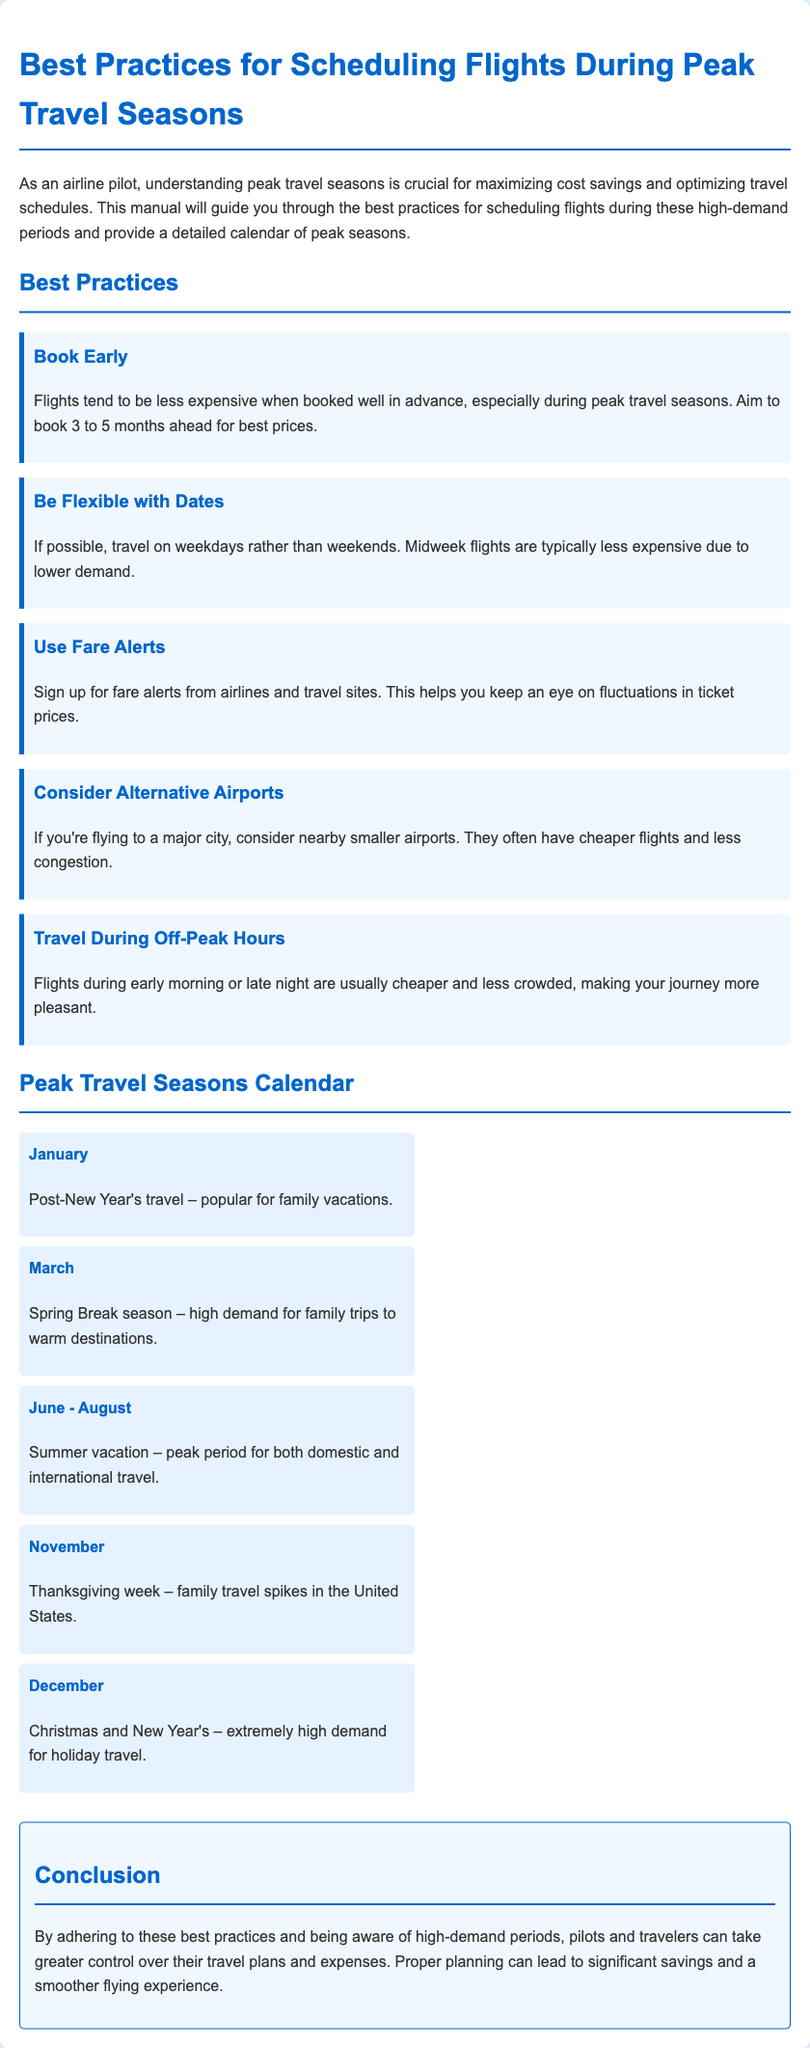what is a best practice for booking flights? The document states that booking flights early, specifically 3 to 5 months ahead, leads to the best prices.
Answer: Book early what is the peak travel season for Christmas? The document indicates that December experiences extremely high demand for holiday travel due to Christmas and New Year's.
Answer: December which month is highlighted for Spring Break travel demand? The document mentions March as the high-demand period for family trips during Spring Break.
Answer: March how can travelers save on flights to major cities? According to the document, travelers can consider nearby smaller airports as they often have cheaper flights and less congestion.
Answer: Alternative airports which travel period is noted for Thanksgiving? The document specifies that November is a high-demand month due to family travel spikes for Thanksgiving.
Answer: November what weekdays are typically less expensive for flights? The document suggests that midweek flights are usually less expensive because of lower demand.
Answer: Weekdays what is a key recommendation for off-peak travel? The document advises travelers to consider flights during early morning or late night for cheaper, less crowded journeys.
Answer: Off-peak hours how many peak travel seasons are mentioned in the document? The document lists 5 specific peak travel seasons throughout the year.
Answer: Five what practice helps monitor changes in ticket prices? The document recommends signing up for fare alerts to keep an eye on ticket price fluctuations.
Answer: Fare alerts 